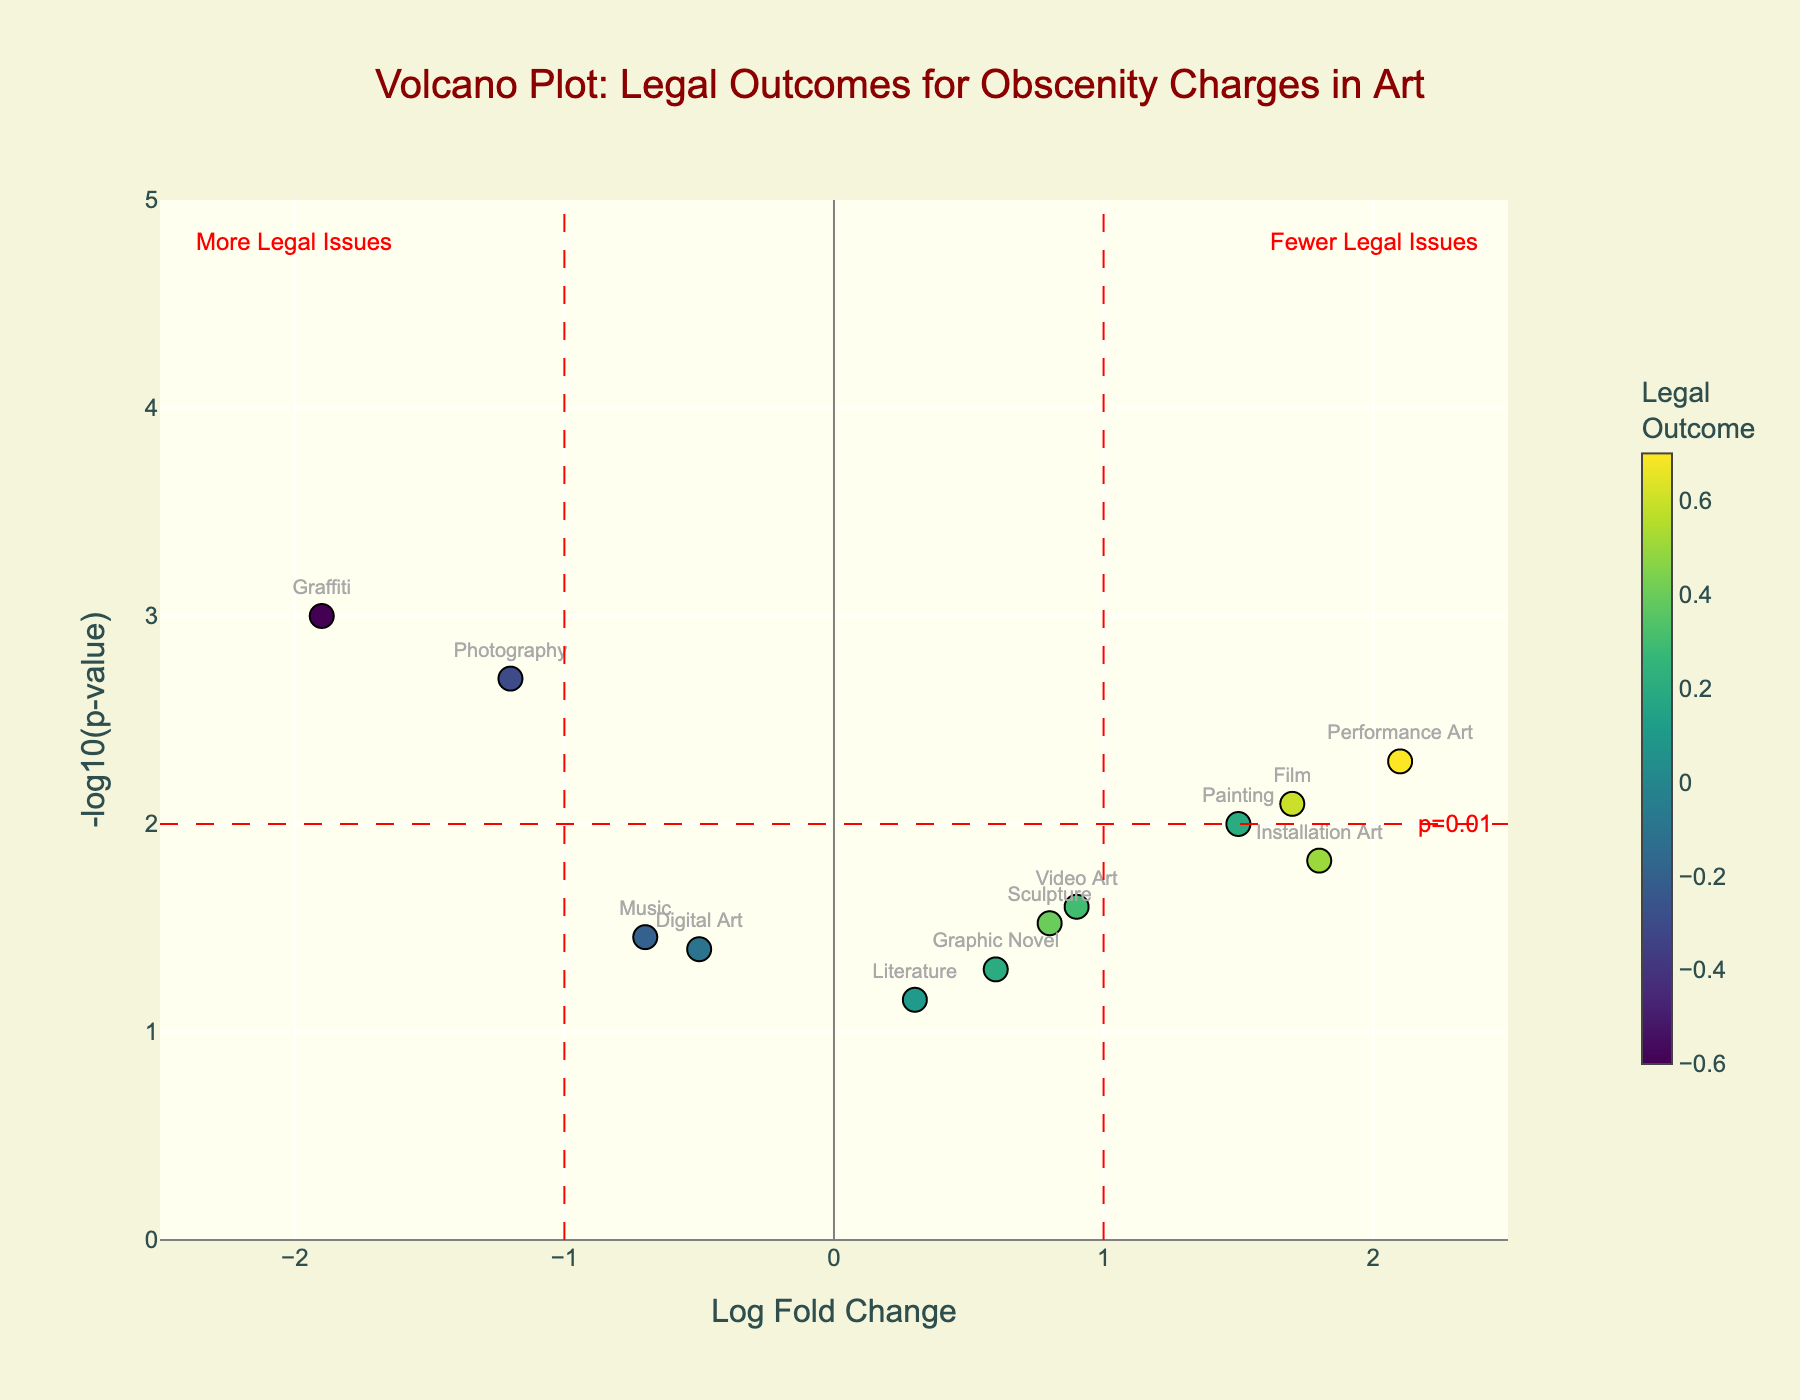Which artistic medium has the highest legal outcome? By observing the color scale on the right, the color intensity indicates the legal outcome values. The highest legal outcome corresponds to the brightest color. Performance Art has the brightest color, indicating the highest legal outcome.
Answer: Performance Art Which artistic medium is associated with the lowest p-value? In the figure, the y-axis represents the -log10(p-value). The highest value on this axis corresponds to the lowest p-value. Graffiti has the highest y-axis value.
Answer: Graffiti Which artistic medium has a log fold change close to 0 and a p-value higher than 0.01? A log fold change close to 0 will be near the center of the x-axis, and a -log10(p-value) lower than 2 will be near the bottom of the y-axis. Digital Art fits these criteria.
Answer: Digital Art Which two artistic mediums are closest in terms of legal outcomes and p-values? By examining the color and position of the points in the plot, Painting and Graphic Novel appear close together both in terms of color shade and their positions on the plot.
Answer: Painting and Graphic Novel How many artistic mediums have a p-value less than 0.05? We look for points above the horizontal red dashed line (y = 1.3, which represents -log10(0.05)). Those points are Painting, Sculpture, Photography, Performance Art, Installation Art, Video Art, Graffiti, Film, and Music.
Answer: 9 What is the legal outcome value for Sculpture? By checking the color of the Sculpture point and referencing the color scale, we see that it has a mid-range yellow/green shade, corresponding to a legal outcome of 0.8.
Answer: 0.8 Which artistic medium has the highest p-value but did not exceed the significance threshold of 0.01? The highest p-value translates to the lowest y-axis value (near the bottom). Literature is the point closest to the threshold without exceeding it.
Answer: Literature 